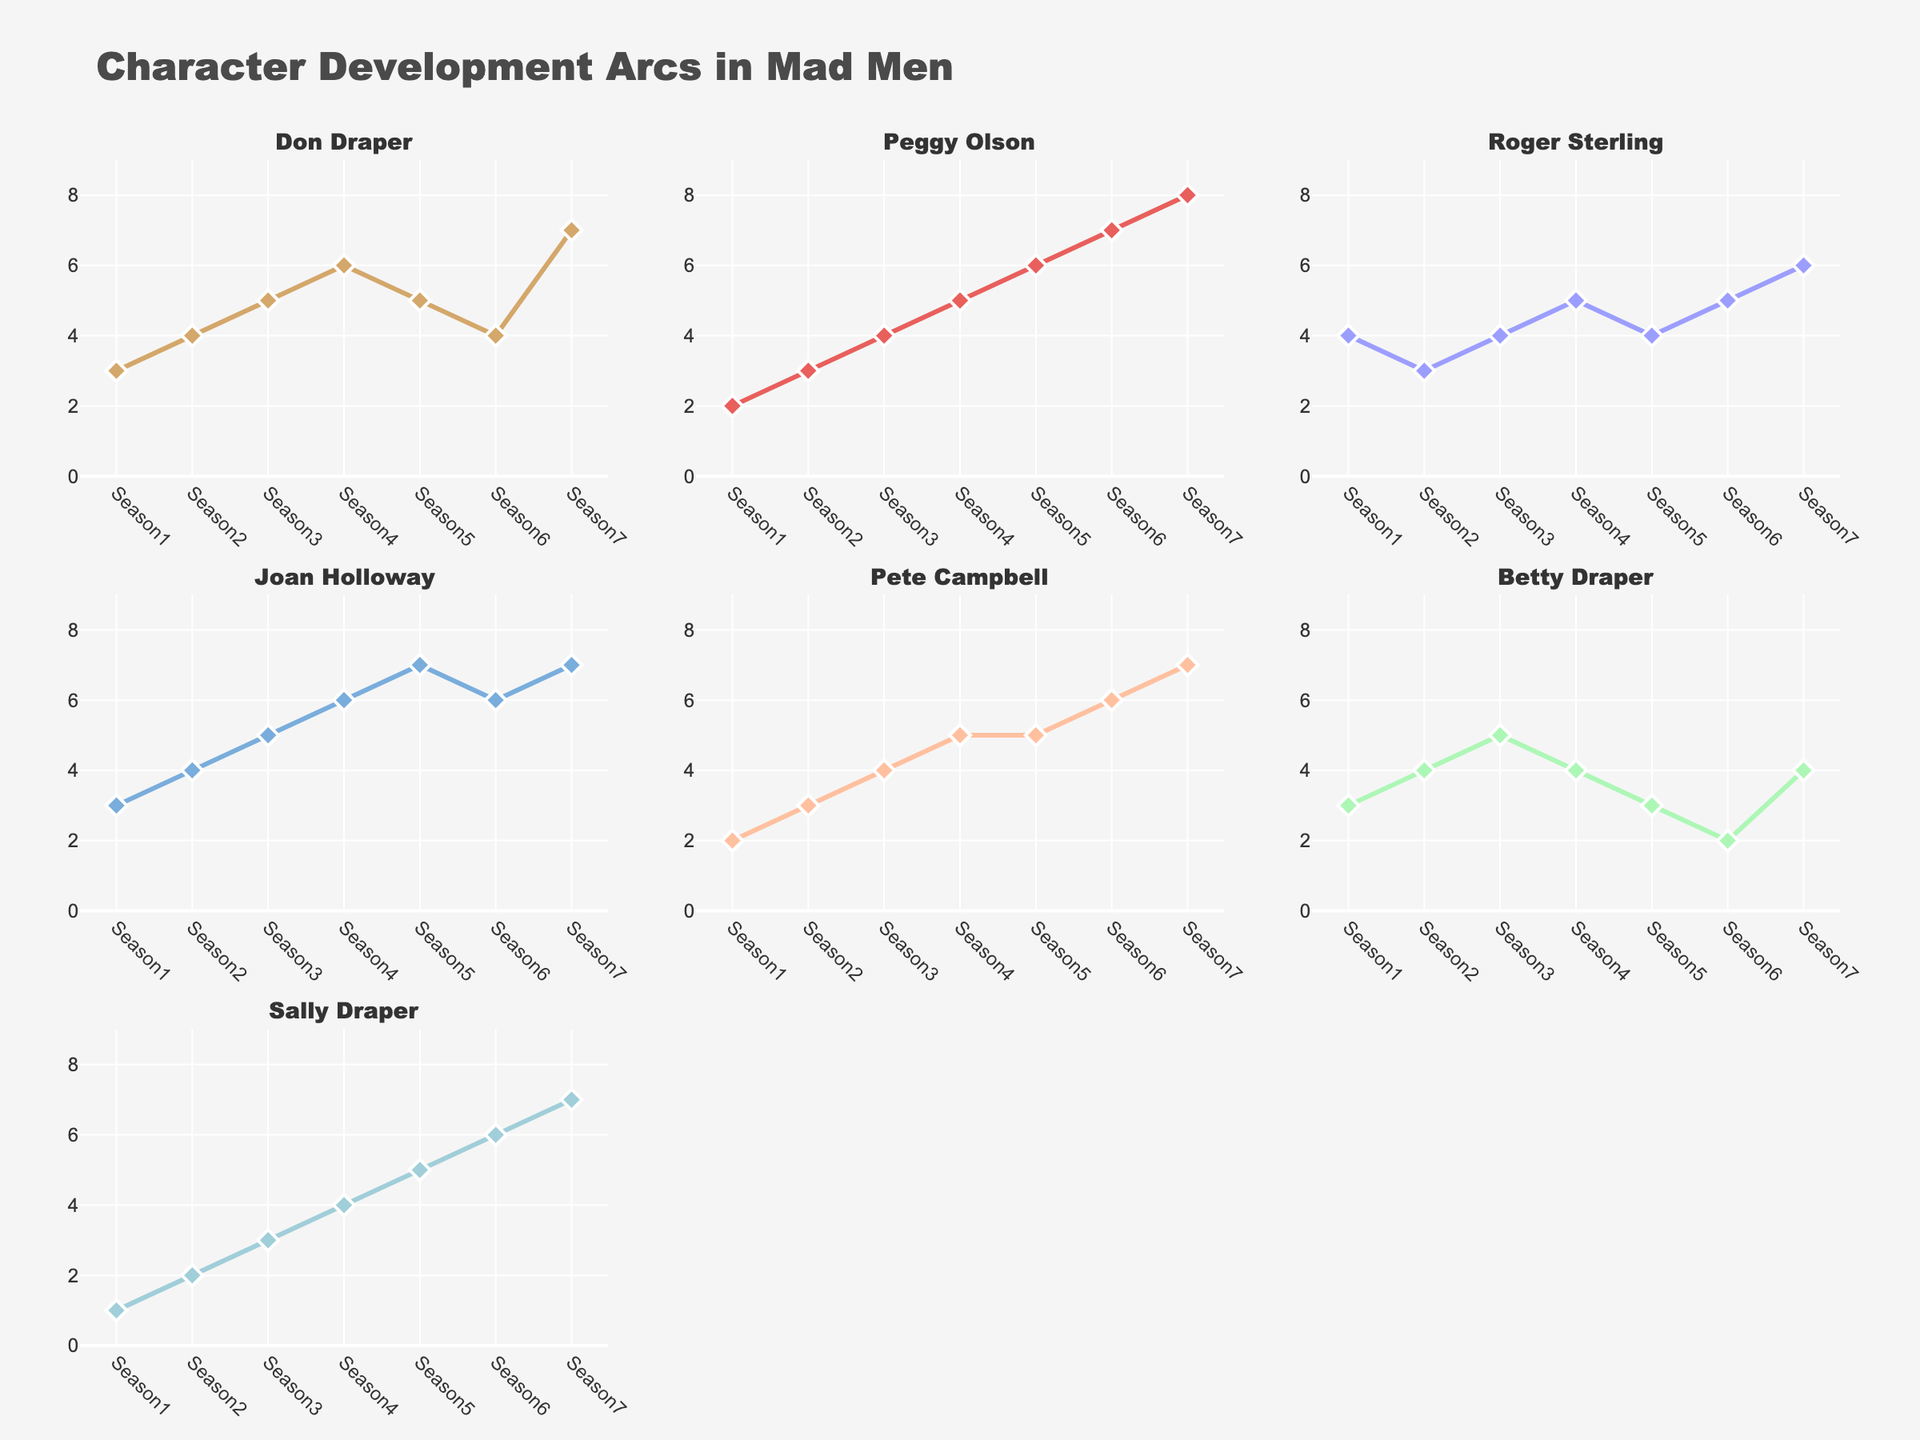What state has the highest incarceration rate for Black people with low income? In the plot for each state, we observe the bar for Black people with low income. Texas has the highest bar among all states for Black people with low income.
Answer: Texas What is the title of the figure? The title is found at the top of the figure and summarizes the content of the plot. It reads "Incarceration Rates by Race, Income Level, and State".
Answer: Incarceration Rates by Race, Income Level, and State Which population group has the lowest incarceration rate in New York? By examining the bars in the New York subplot, we can see that White people with high income have the lowest incarceration rate, as this bar is the shortest.
Answer: White people with high income Compare the incarceration rates of Hispanic people with middle income in California and Texas. Which state has a higher rate? Looking at the bars for Hispanic people with middle income in both the California and Texas subplots, the bar for Texas is higher than that for California, indicating a higher incarceration rate.
Answer: Texas What can you infer about the relationship between income level and incarceration rate across all subplots? By comparing the heights of the bars within each race category, we see a consistent trend where higher income levels correspond to lower incarceration rates for all races and states.
Answer: Higher income levels correspond to lower incarceration rates What is the overall trend for incarceration rates among White people across different income levels in Texas? By inspecting the bars representing White people in Texas, we see that the incarceration rate decreases as the income level increases.
Answer: Decreases as income increases Which subgroup has the highest incarceration rate in the entire figure? The Black people with low income in Texas have the highest bar in the figure, indicating the highest incarceration rate among all subgroups.
Answer: Black people with low income in Texas What are the incarceration rates for Black people in New York for each income level? Examining the New York subplot for Black people, the bars indicate rates of 874 for low income, 502 for middle income, and 176 for high income.
Answer: 874 (low), 502 (middle), 176 (high) How do the incarceration rates for Hispanic people with high income compare between Texas and New York? Looking at the bars for Hispanic people with high income in the Texas and New York subplots, Texas's bar is slightly higher than New York's, showing a higher rate.
Answer: Texas is higher What is the difference in incarceration rates between White people with low income and Black people with high income in California? In the California subplot, locating the bars for White people with low income (152) and Black people with high income (211), the difference is 211 - 152 = 59.
Answer: 59 